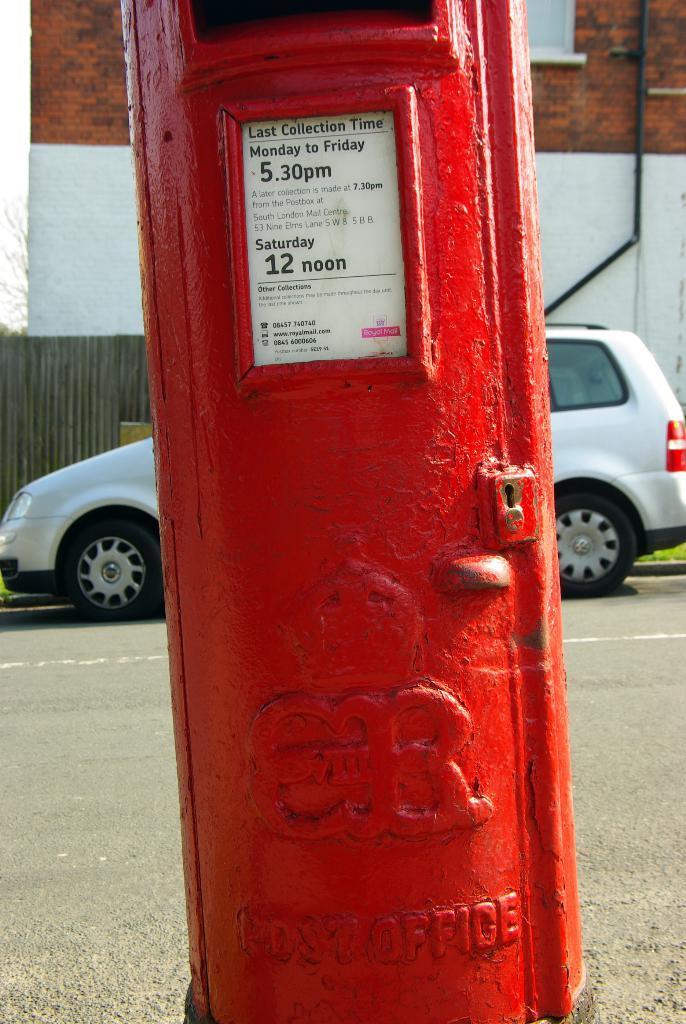Please provide a concise description of this image. In this image we can see a red color post box, behind the post box we can see a white color vehicle, in the background, we can see the wall and also we can see the sky. 